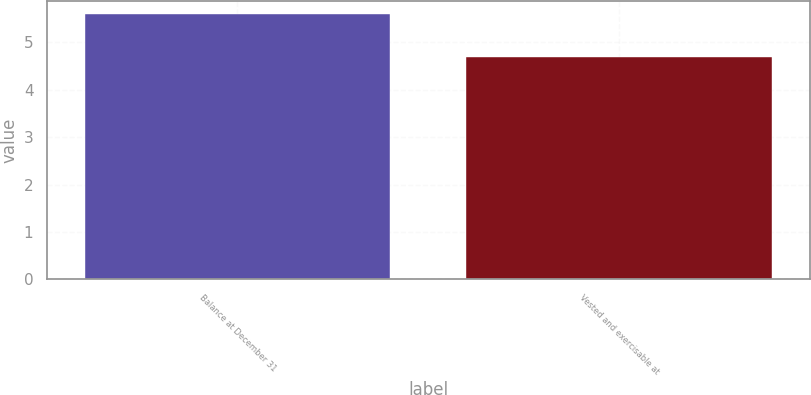<chart> <loc_0><loc_0><loc_500><loc_500><bar_chart><fcel>Balance at December 31<fcel>Vested and exercisable at<nl><fcel>5.6<fcel>4.7<nl></chart> 